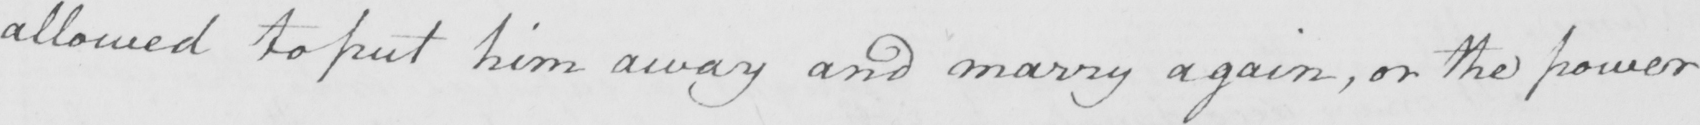What does this handwritten line say? allowed to put him away and marry again , or the power 